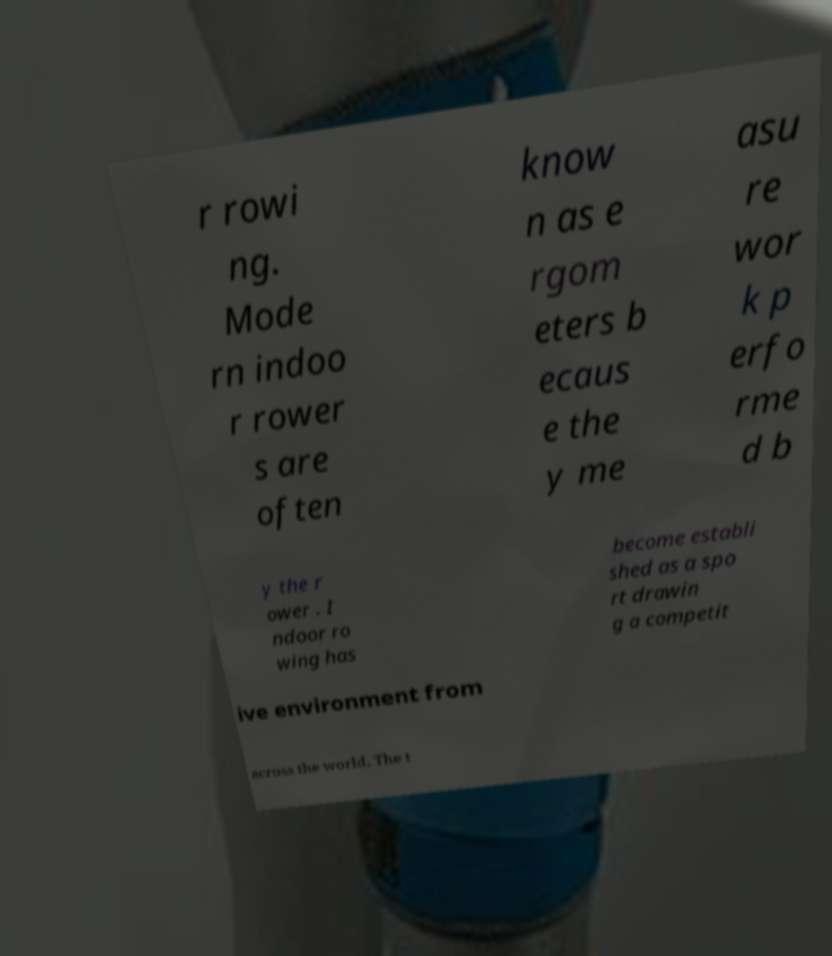Can you read and provide the text displayed in the image?This photo seems to have some interesting text. Can you extract and type it out for me? r rowi ng. Mode rn indoo r rower s are often know n as e rgom eters b ecaus e the y me asu re wor k p erfo rme d b y the r ower . I ndoor ro wing has become establi shed as a spo rt drawin g a competit ive environment from across the world. The t 